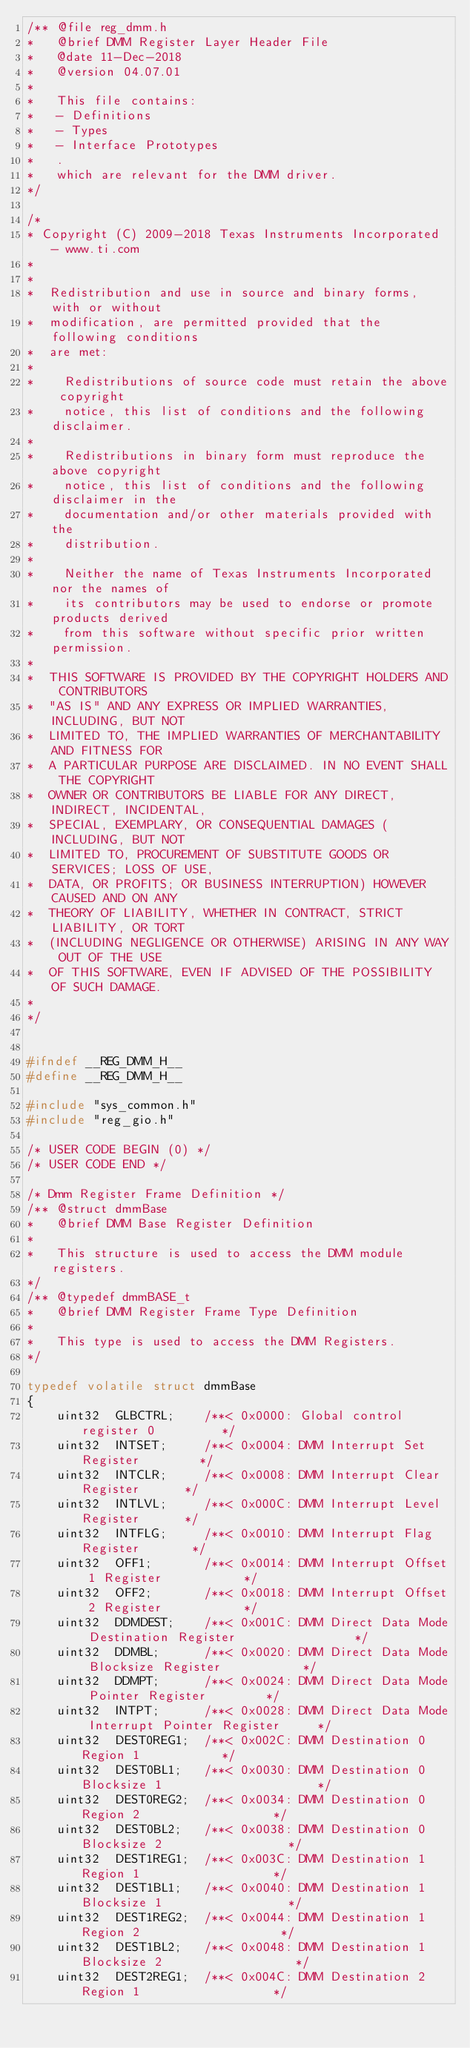Convert code to text. <code><loc_0><loc_0><loc_500><loc_500><_C_>/** @file reg_dmm.h
*   @brief DMM Register Layer Header File
*   @date 11-Dec-2018
*   @version 04.07.01
*   
*   This file contains:
*   - Definitions
*   - Types
*   - Interface Prototypes
*   .
*   which are relevant for the DMM driver.
*/

/* 
* Copyright (C) 2009-2018 Texas Instruments Incorporated - www.ti.com  
* 
* 
*  Redistribution and use in source and binary forms, with or without 
*  modification, are permitted provided that the following conditions 
*  are met:
*
*    Redistributions of source code must retain the above copyright 
*    notice, this list of conditions and the following disclaimer.
*
*    Redistributions in binary form must reproduce the above copyright
*    notice, this list of conditions and the following disclaimer in the 
*    documentation and/or other materials provided with the   
*    distribution.
*
*    Neither the name of Texas Instruments Incorporated nor the names of
*    its contributors may be used to endorse or promote products derived
*    from this software without specific prior written permission.
*
*  THIS SOFTWARE IS PROVIDED BY THE COPYRIGHT HOLDERS AND CONTRIBUTORS 
*  "AS IS" AND ANY EXPRESS OR IMPLIED WARRANTIES, INCLUDING, BUT NOT 
*  LIMITED TO, THE IMPLIED WARRANTIES OF MERCHANTABILITY AND FITNESS FOR
*  A PARTICULAR PURPOSE ARE DISCLAIMED. IN NO EVENT SHALL THE COPYRIGHT 
*  OWNER OR CONTRIBUTORS BE LIABLE FOR ANY DIRECT, INDIRECT, INCIDENTAL, 
*  SPECIAL, EXEMPLARY, OR CONSEQUENTIAL DAMAGES (INCLUDING, BUT NOT 
*  LIMITED TO, PROCUREMENT OF SUBSTITUTE GOODS OR SERVICES; LOSS OF USE,
*  DATA, OR PROFITS; OR BUSINESS INTERRUPTION) HOWEVER CAUSED AND ON ANY
*  THEORY OF LIABILITY, WHETHER IN CONTRACT, STRICT LIABILITY, OR TORT 
*  (INCLUDING NEGLIGENCE OR OTHERWISE) ARISING IN ANY WAY OUT OF THE USE 
*  OF THIS SOFTWARE, EVEN IF ADVISED OF THE POSSIBILITY OF SUCH DAMAGE.
*
*/


#ifndef __REG_DMM_H__
#define __REG_DMM_H__

#include "sys_common.h"
#include "reg_gio.h"

/* USER CODE BEGIN (0) */
/* USER CODE END */

/* Dmm Register Frame Definition */
/** @struct dmmBase
*   @brief DMM Base Register Definition
*
*   This structure is used to access the DMM module registers.
*/
/** @typedef dmmBASE_t
*   @brief DMM Register Frame Type Definition
*
*   This type is used to access the DMM Registers.
*/

typedef volatile struct dmmBase
{
    uint32  GLBCTRL;    /**< 0x0000: Global control register 0         */
    uint32  INTSET;     /**< 0x0004: DMM Interrupt Set Register        */    
    uint32  INTCLR;     /**< 0x0008: DMM Interrupt Clear Register      */
    uint32  INTLVL;     /**< 0x000C: DMM Interrupt Level Register      */    
    uint32  INTFLG;     /**< 0x0010: DMM Interrupt Flag Register       */
    uint32  OFF1;       /**< 0x0014: DMM Interrupt Offset 1 Register           */
    uint32  OFF2;       /**< 0x0018: DMM Interrupt Offset 2 Register           */
    uint32  DDMDEST;    /**< 0x001C: DMM Direct Data Mode Destination Register                */
    uint32  DDMBL;      /**< 0x0020: DMM Direct Data Mode Blocksize Register           */
    uint32  DDMPT;      /**< 0x0024: DMM Direct Data Mode Pointer Register        */
    uint32  INTPT;      /**< 0x0028: DMM Direct Data Mode Interrupt Pointer Register     */
    uint32  DEST0REG1;  /**< 0x002C: DMM Destination 0 Region 1           */
    uint32  DEST0BL1;   /**< 0x0030: DMM Destination 0 Blocksize 1                     */
    uint32  DEST0REG2;  /**< 0x0034: DMM Destination 0 Region 2                  */
    uint32  DEST0BL2;   /**< 0x0038: DMM Destination 0 Blocksize 2                 */
    uint32  DEST1REG1;  /**< 0x003C: DMM Destination 1 Region 1                  */
    uint32  DEST1BL1;   /**< 0x0040: DMM Destination 1 Blocksize 1                 */
    uint32  DEST1REG2;  /**< 0x0044: DMM Destination 1 Region 2                   */
    uint32  DEST1BL2;   /**< 0x0048: DMM Destination 1 Blocksize 2                  */
    uint32  DEST2REG1;  /**< 0x004C: DMM Destination 2 Region 1                  */</code> 